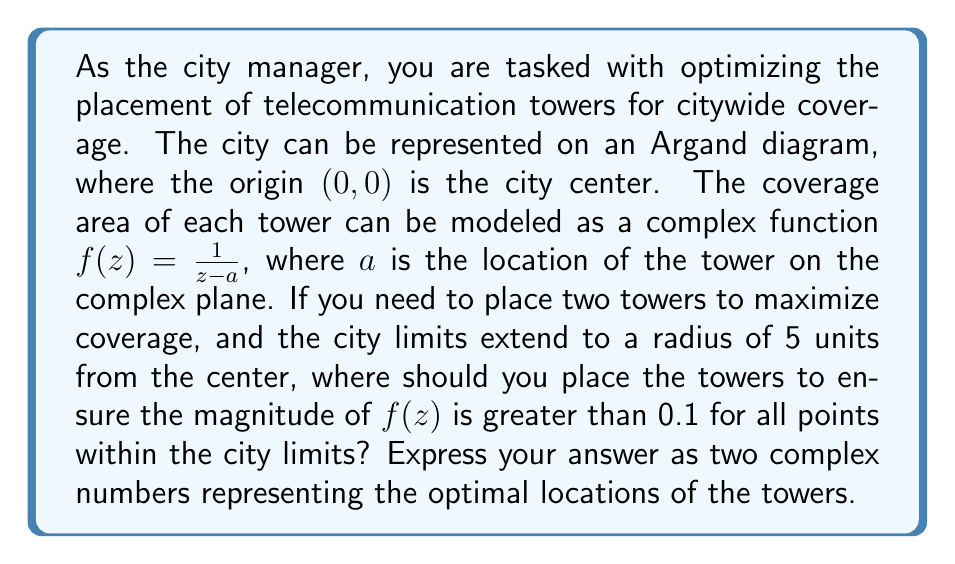Show me your answer to this math problem. To solve this problem, we need to consider the following steps:

1) The function $f(z) = \frac{1}{z-a}$ represents the coverage of a single tower located at point $a$.

2) We want $|f(z)| > 0.1$ for all points $z$ within the city limits. This means:

   $$|\frac{1}{z-a}| > 0.1$$

3) Solving this inequality:

   $$\frac{1}{|z-a|} > 0.1$$
   $$|z-a| < 10$$

4) This means that each point in the city should be within 10 units of at least one tower.

5) The city limits extend to a radius of 5 units from the center. To cover this area with two towers, we can place them on opposite sides of the city center, each 5 units away.

6) On the Argand diagram, we can represent these points as:

   $a_1 = 5$ (5 units to the right of center)
   $a_2 = -5$ (5 units to the left of center)

7) With this placement, any point within the city limits will be at most 10 units away from at least one of the towers, ensuring that $|f(z)| > 0.1$ for all points within the city.

[asy]
import graph;
size(200);
draw(circle((0,0),5));
dot((5,0),red);
dot((-5,0),red);
label("City Center",(0,0),S);
label("Tower 1",(5,0),E);
label("Tower 2",(-5,0),W);
[/asy]
Answer: The optimal locations for the two towers are $a_1 = 5$ and $a_2 = -5$. 